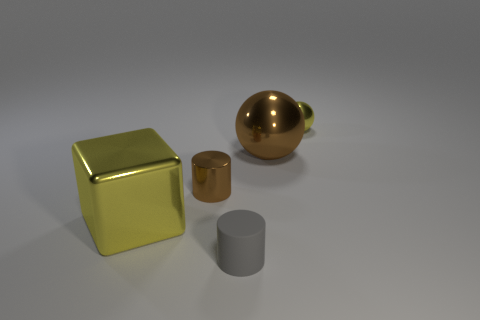What number of things are big brown metallic objects or yellow shiny objects that are behind the big yellow cube?
Keep it short and to the point. 2. Is the small ball made of the same material as the big yellow block?
Provide a succinct answer. Yes. How many other objects are there of the same material as the small yellow sphere?
Your response must be concise. 3. Is the number of purple matte things greater than the number of brown metallic cylinders?
Your answer should be very brief. No. Do the big metal thing behind the large block and the small brown thing have the same shape?
Your response must be concise. No. Is the number of yellow balls less than the number of large yellow rubber cylinders?
Keep it short and to the point. No. What is the material of the gray thing that is the same size as the yellow shiny sphere?
Give a very brief answer. Rubber. There is a large cube; is its color the same as the small shiny object to the right of the small brown cylinder?
Provide a succinct answer. Yes. Is the number of gray things on the left side of the yellow block less than the number of tiny brown matte things?
Give a very brief answer. No. What number of tiny purple rubber cylinders are there?
Provide a short and direct response. 0. 